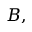Convert formula to latex. <formula><loc_0><loc_0><loc_500><loc_500>B ,</formula> 